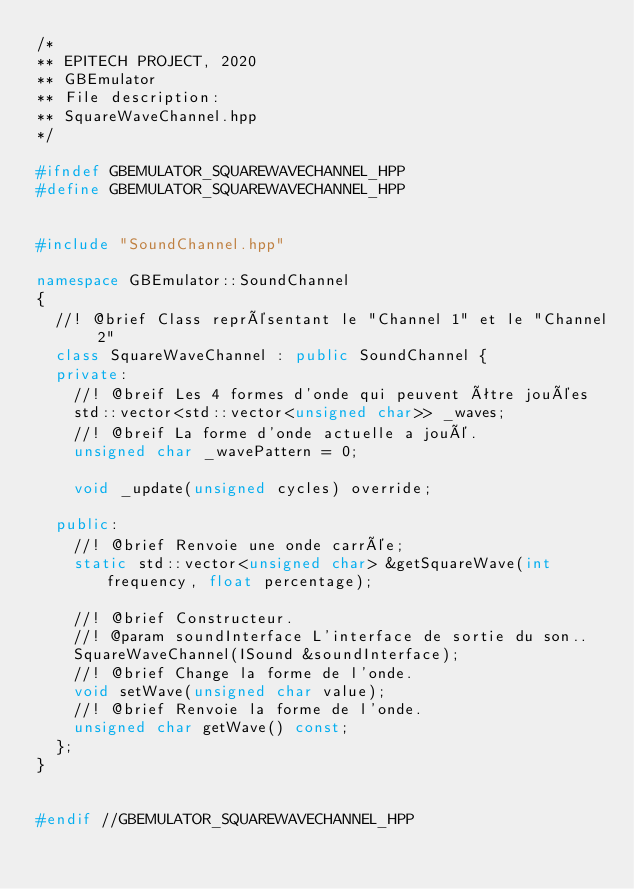Convert code to text. <code><loc_0><loc_0><loc_500><loc_500><_C++_>/*
** EPITECH PROJECT, 2020
** GBEmulator
** File description:
** SquareWaveChannel.hpp
*/

#ifndef GBEMULATOR_SQUAREWAVECHANNEL_HPP
#define GBEMULATOR_SQUAREWAVECHANNEL_HPP


#include "SoundChannel.hpp"

namespace GBEmulator::SoundChannel
{
	//! @brief Class représentant le "Channel 1" et le "Channel 2"
	class SquareWaveChannel : public SoundChannel {
	private:
		//! @breif Les 4 formes d'onde qui peuvent être jouées
		std::vector<std::vector<unsigned char>> _waves;
		//! @breif La forme d'onde actuelle a joué.
		unsigned char _wavePattern = 0;

		void _update(unsigned cycles) override;

	public:
		//! @brief Renvoie une onde carrée;
		static std::vector<unsigned char> &getSquareWave(int frequency, float percentage);

		//! @brief Constructeur.
		//! @param soundInterface L'interface de sortie du son..
		SquareWaveChannel(ISound &soundInterface);
		//! @brief Change la forme de l'onde.
		void setWave(unsigned char value);
		//! @brief Renvoie la forme de l'onde.
		unsigned char getWave() const;
	};
}


#endif //GBEMULATOR_SQUAREWAVECHANNEL_HPP
</code> 